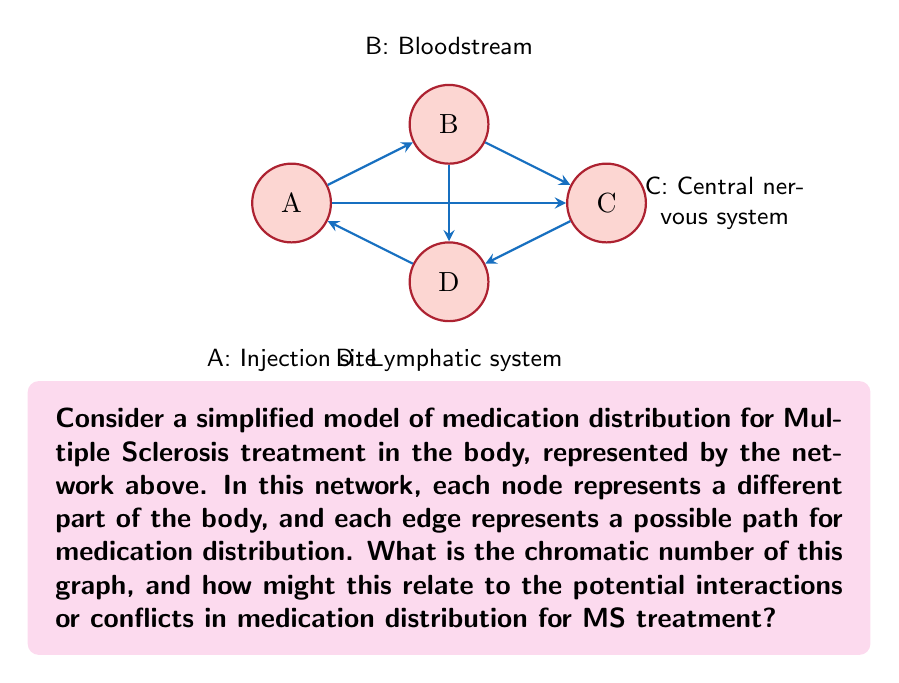Give your solution to this math problem. Let's approach this step-by-step:

1) First, we need to understand what the chromatic number means. The chromatic number of a graph is the minimum number of colors needed to color the vertices of the graph such that no two adjacent vertices share the same color.

2) To find the chromatic number, let's try to color the graph:
   - Start with node A. We can color it with color 1.
   - Node B is connected to A, so it needs a different color. Color it with color 2.
   - Node C is connected to B, so it can't be color 2. It's also connected to A, so it can't be color 1. Give it color 3.
   - Node D is connected to A and C, so it can't be colors 1 or 3. But it can be color 2, as it's not connected to B.

3) We've successfully colored the graph with 3 colors, and it's impossible to do it with fewer colors because of the triangle formed by A, B, and C.

4) Therefore, the chromatic number of this graph is 3.

5) In the context of MS medication distribution:
   - The chromatic number can represent the minimum number of distinct "phases" or "stages" in the medication distribution process.
   - Each color (or phase) might represent a different biochemical environment or a time period in the distribution process.
   - For example:
     * Color 1: Initial injection phase
     * Color 2: Bloodstream circulation phase
     * Color 3: Central nervous system absorption phase

6) The fact that adjacent nodes can't share colors suggests that these phases must be distinct and can't overlap in time or space. This could relate to potential interactions or conflicts in medication distribution:
   - The medication might need to undergo changes as it moves between phases.
   - There might be a need for timing considerations to avoid negative interactions between phases.
   - Different parts of the body (nodes) that share a color might be able to receive the medication simultaneously, while those with different colors would need to be treated sequentially.

This topological analysis provides insights into the complexity of medication distribution for MS treatment and highlights the need for carefully planned drug delivery strategies.
Answer: 3; represents minimum distinct phases in medication distribution process 